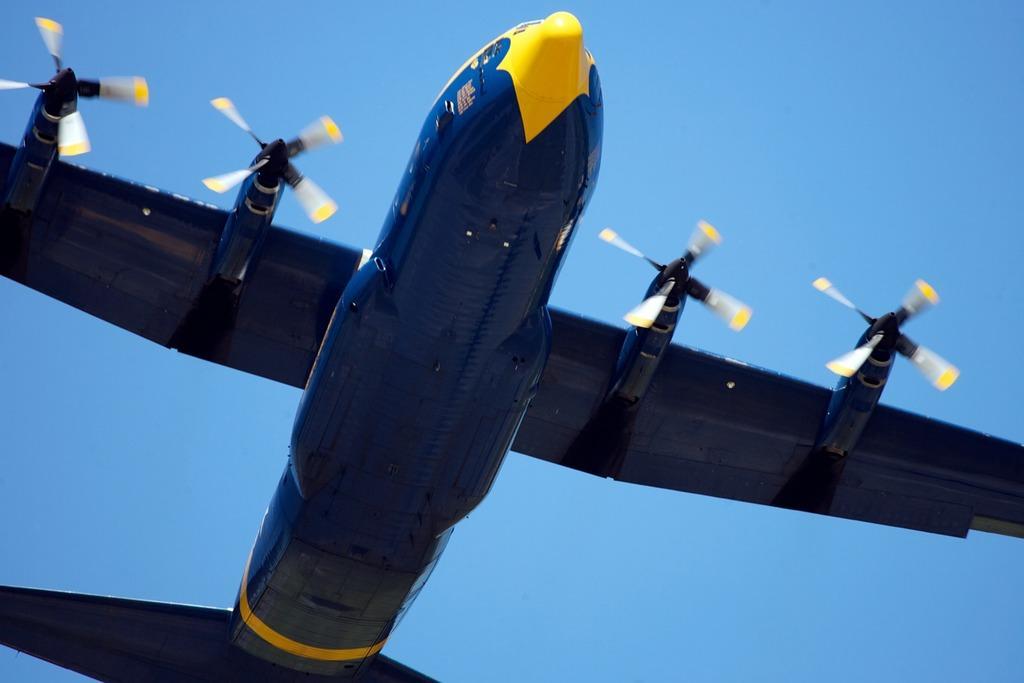In one or two sentences, can you explain what this image depicts? In this picture we can see an aircraft in the sky. Sky is blue in color. 